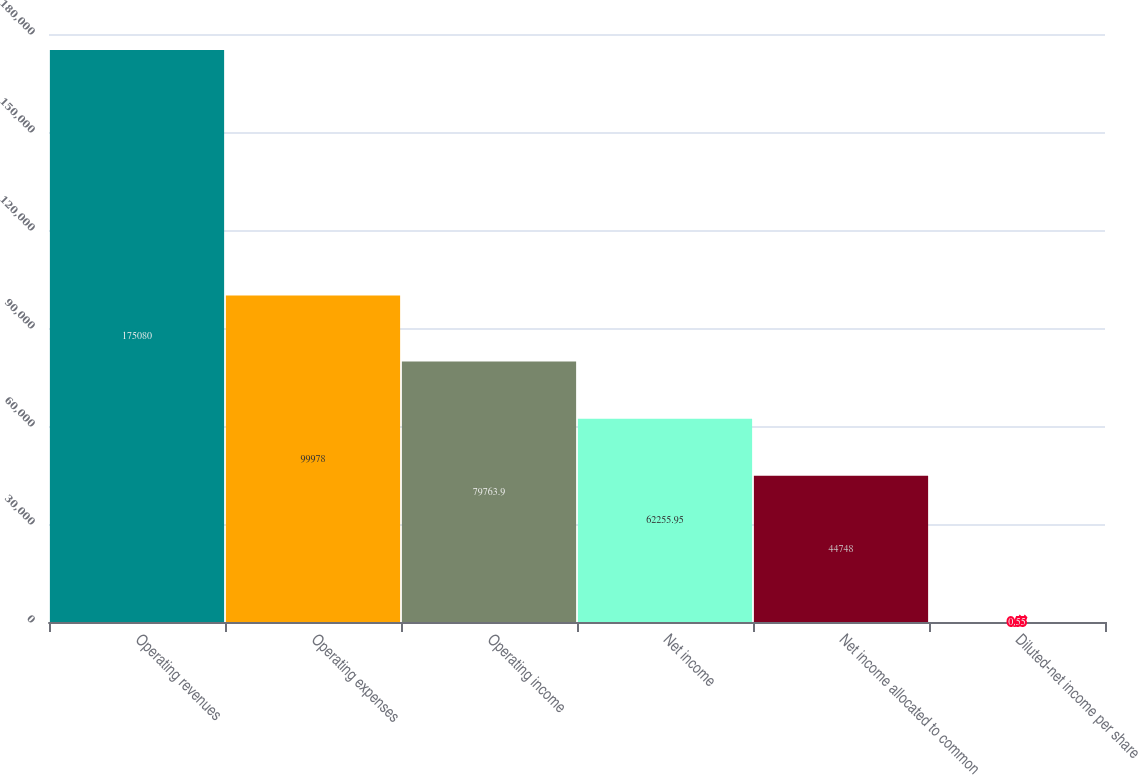Convert chart to OTSL. <chart><loc_0><loc_0><loc_500><loc_500><bar_chart><fcel>Operating revenues<fcel>Operating expenses<fcel>Operating income<fcel>Net income<fcel>Net income allocated to common<fcel>Diluted-net income per share<nl><fcel>175080<fcel>99978<fcel>79763.9<fcel>62255.9<fcel>44748<fcel>0.55<nl></chart> 